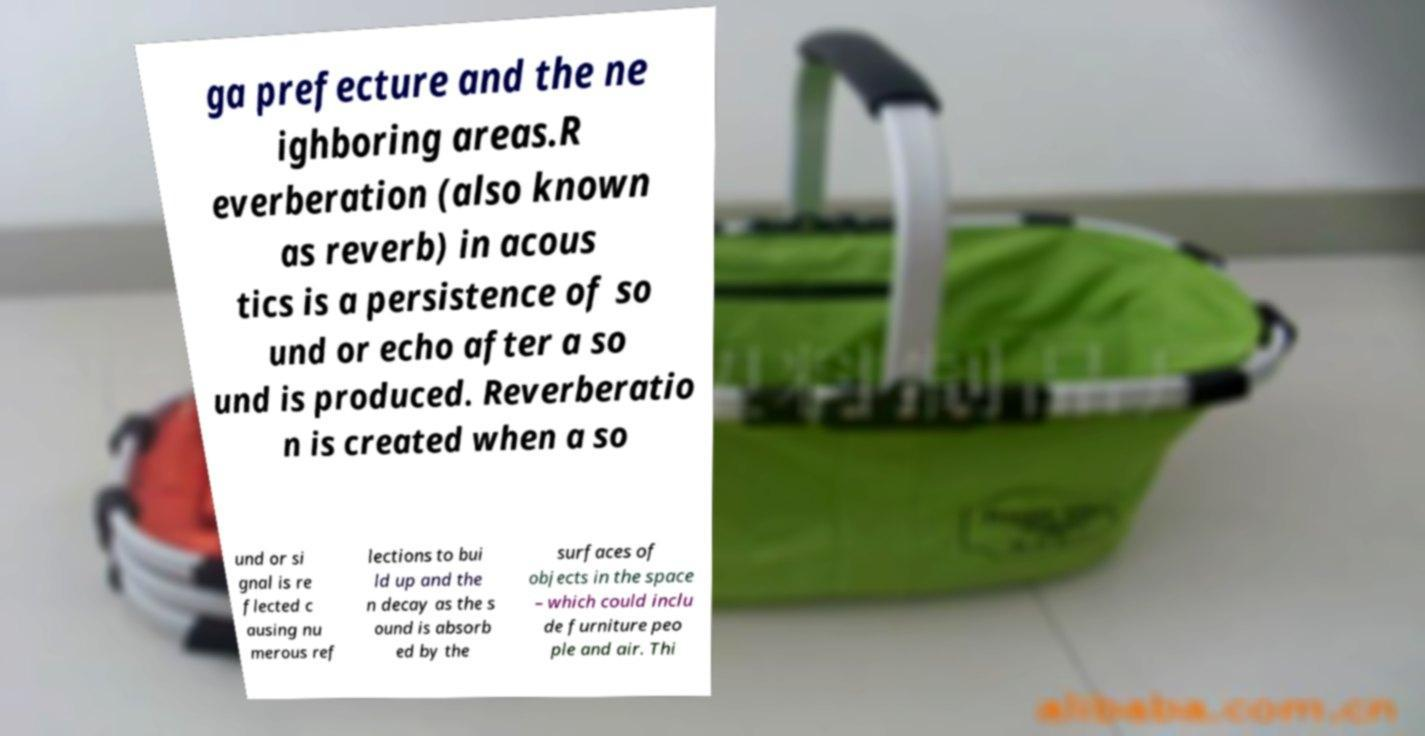Please read and relay the text visible in this image. What does it say? ga prefecture and the ne ighboring areas.R everberation (also known as reverb) in acous tics is a persistence of so und or echo after a so und is produced. Reverberatio n is created when a so und or si gnal is re flected c ausing nu merous ref lections to bui ld up and the n decay as the s ound is absorb ed by the surfaces of objects in the space – which could inclu de furniture peo ple and air. Thi 